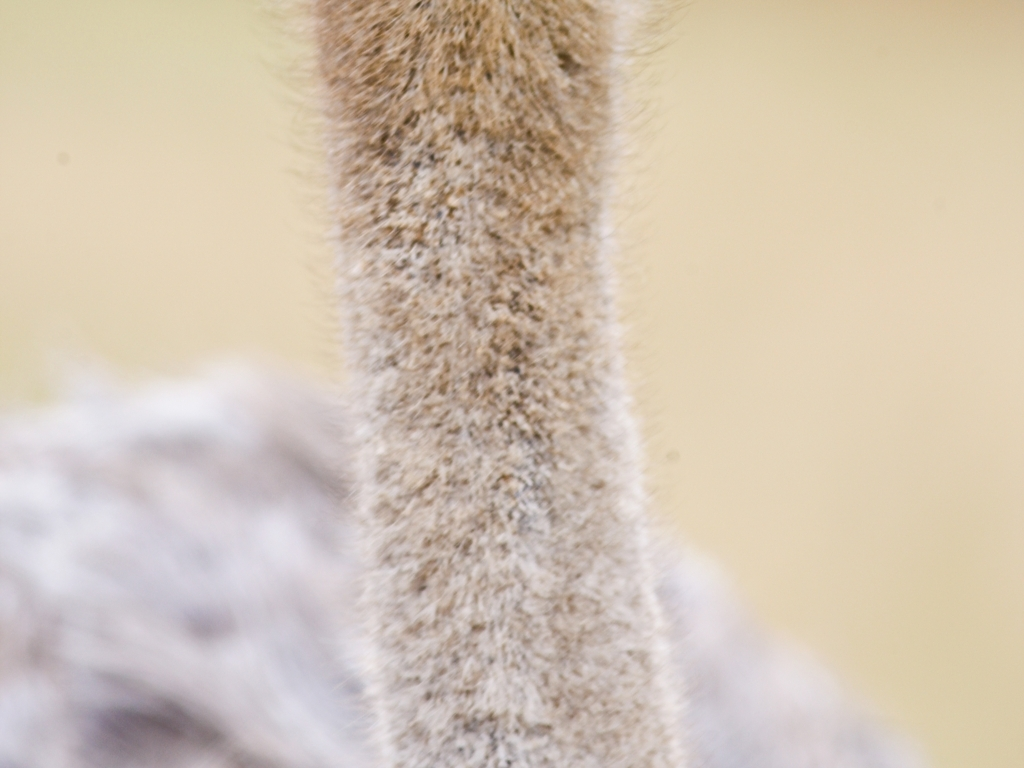Are there focusing issues resulting in only partial display of the details of the animal's legs? Yes, the image appears to have focusing issues, as the details of the animal's legs are not clearly visible with only certain portions being sharp while the rest are blurred. This indicates that the depth of field is shallow, which could be due to camera settings during the moment of capture or intentional artistic choice. 